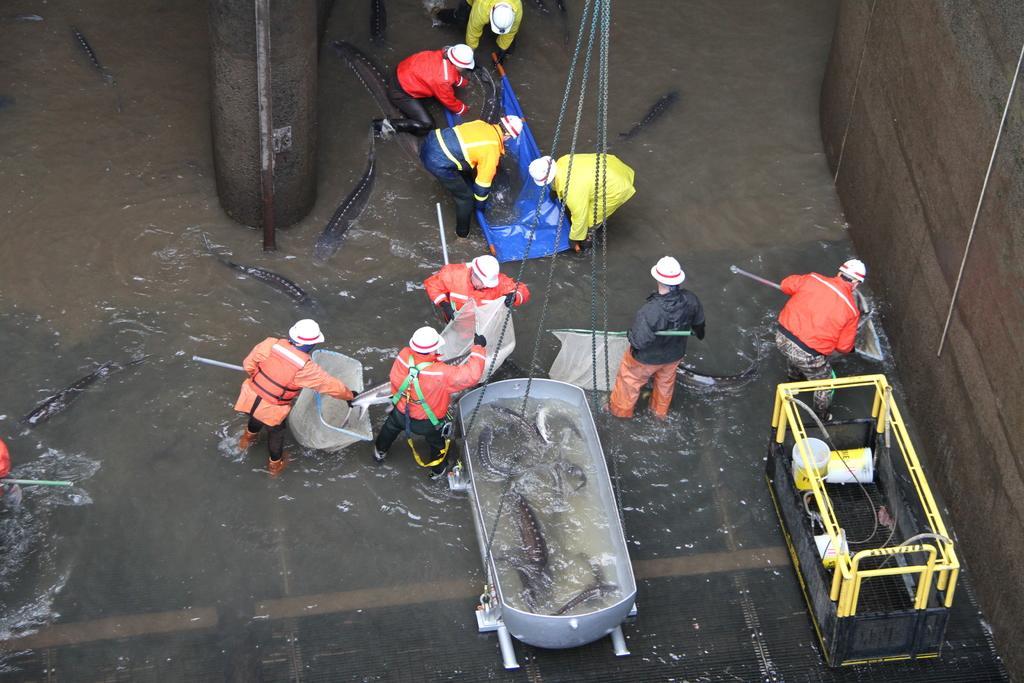How would you summarize this image in a sentence or two? In this image I can see a group of people are catching fishes from the water and machines, wall, metal rods, lifters and nets. This image is taken may be in the water. 